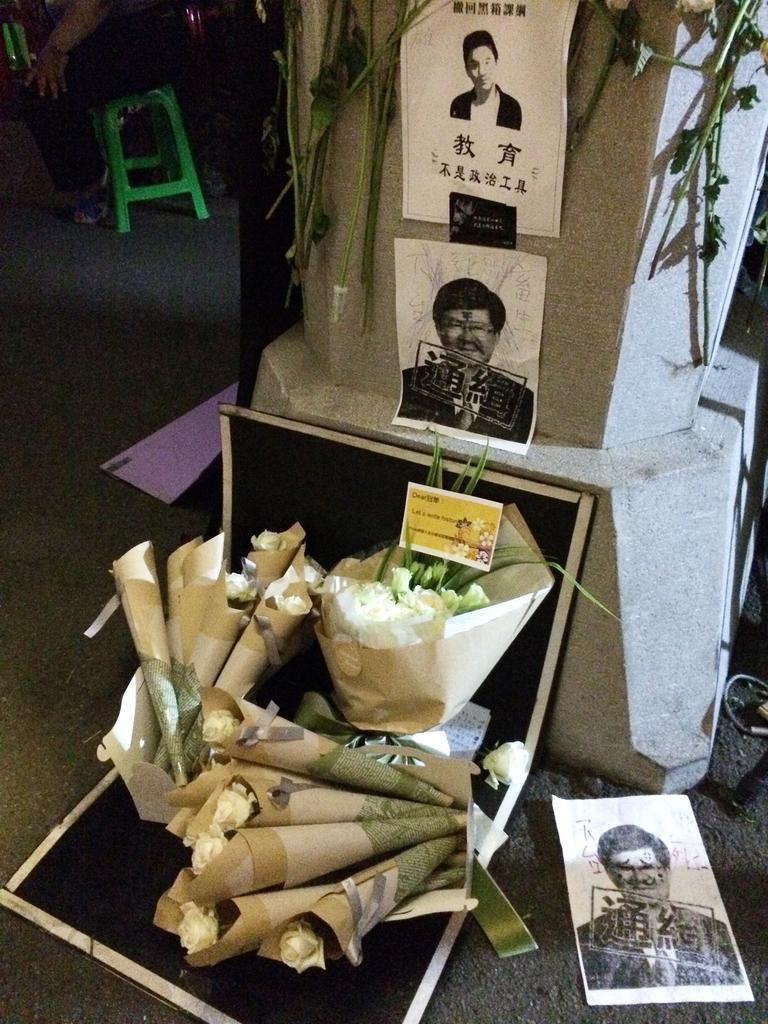How would you summarize this image in a sentence or two? In this picture we can see flowers, stems, posters, card, cone shaped objects and some objects and in the background we can see a person sitting on a stool and this stool is on the floor. 